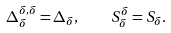<formula> <loc_0><loc_0><loc_500><loc_500>\Delta ^ { \delta , \delta } _ { \delta } = \Delta _ { \delta } , \quad S ^ { \delta } _ { \delta } = S _ { \delta } .</formula> 